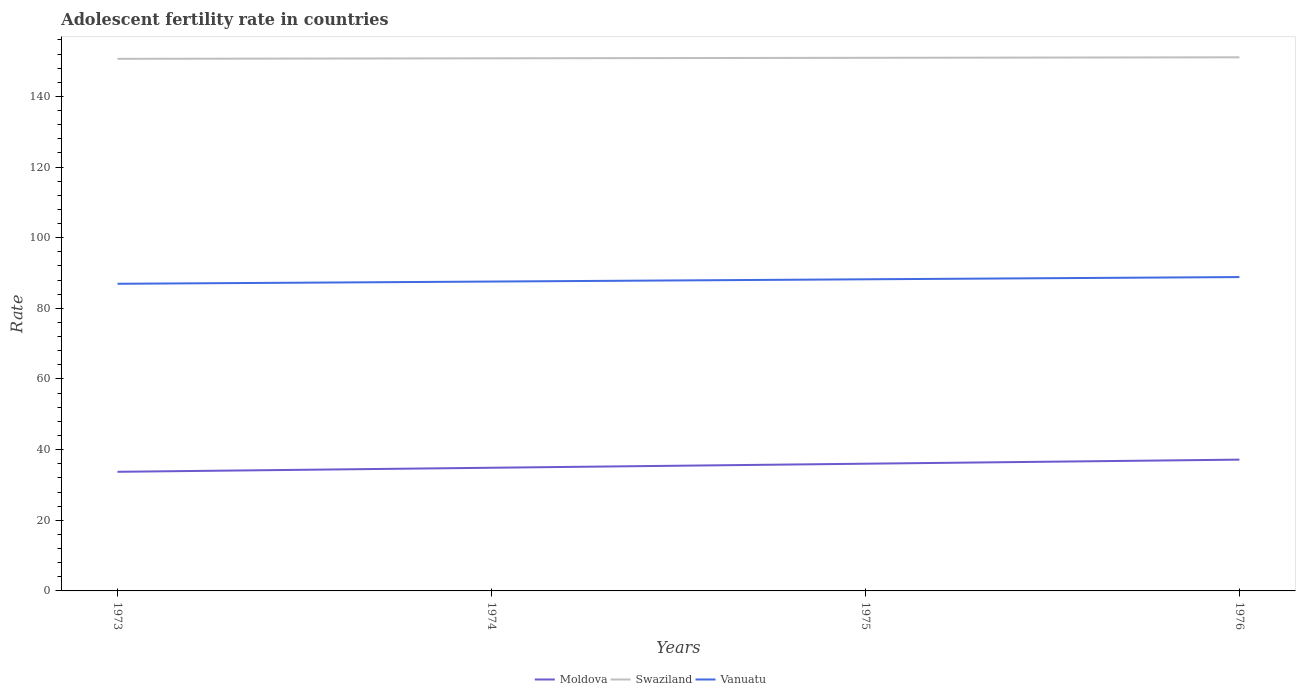How many different coloured lines are there?
Provide a short and direct response. 3. Is the number of lines equal to the number of legend labels?
Offer a very short reply. Yes. Across all years, what is the maximum adolescent fertility rate in Swaziland?
Offer a terse response. 150.65. What is the total adolescent fertility rate in Vanuatu in the graph?
Provide a succinct answer. -1.27. What is the difference between the highest and the second highest adolescent fertility rate in Vanuatu?
Make the answer very short. 1.9. How many years are there in the graph?
Ensure brevity in your answer.  4. What is the difference between two consecutive major ticks on the Y-axis?
Make the answer very short. 20. Are the values on the major ticks of Y-axis written in scientific E-notation?
Offer a very short reply. No. Does the graph contain any zero values?
Offer a terse response. No. Does the graph contain grids?
Your answer should be very brief. No. Where does the legend appear in the graph?
Offer a very short reply. Bottom center. How many legend labels are there?
Your answer should be very brief. 3. What is the title of the graph?
Make the answer very short. Adolescent fertility rate in countries. What is the label or title of the Y-axis?
Give a very brief answer. Rate. What is the Rate in Moldova in 1973?
Provide a short and direct response. 33.73. What is the Rate in Swaziland in 1973?
Your answer should be compact. 150.65. What is the Rate in Vanuatu in 1973?
Your answer should be compact. 86.96. What is the Rate in Moldova in 1974?
Provide a succinct answer. 34.87. What is the Rate of Swaziland in 1974?
Provide a short and direct response. 150.79. What is the Rate of Vanuatu in 1974?
Provide a succinct answer. 87.59. What is the Rate of Moldova in 1975?
Provide a succinct answer. 36.02. What is the Rate of Swaziland in 1975?
Your response must be concise. 150.94. What is the Rate in Vanuatu in 1975?
Provide a succinct answer. 88.23. What is the Rate in Moldova in 1976?
Provide a short and direct response. 37.17. What is the Rate of Swaziland in 1976?
Your answer should be very brief. 151.08. What is the Rate in Vanuatu in 1976?
Make the answer very short. 88.86. Across all years, what is the maximum Rate in Moldova?
Your response must be concise. 37.17. Across all years, what is the maximum Rate of Swaziland?
Provide a short and direct response. 151.08. Across all years, what is the maximum Rate in Vanuatu?
Your answer should be very brief. 88.86. Across all years, what is the minimum Rate of Moldova?
Provide a short and direct response. 33.73. Across all years, what is the minimum Rate of Swaziland?
Make the answer very short. 150.65. Across all years, what is the minimum Rate in Vanuatu?
Ensure brevity in your answer.  86.96. What is the total Rate in Moldova in the graph?
Provide a short and direct response. 141.78. What is the total Rate of Swaziland in the graph?
Give a very brief answer. 603.45. What is the total Rate of Vanuatu in the graph?
Your response must be concise. 351.63. What is the difference between the Rate of Moldova in 1973 and that in 1974?
Offer a terse response. -1.15. What is the difference between the Rate in Swaziland in 1973 and that in 1974?
Make the answer very short. -0.14. What is the difference between the Rate in Vanuatu in 1973 and that in 1974?
Your response must be concise. -0.63. What is the difference between the Rate of Moldova in 1973 and that in 1975?
Your answer should be very brief. -2.29. What is the difference between the Rate in Swaziland in 1973 and that in 1975?
Make the answer very short. -0.29. What is the difference between the Rate of Vanuatu in 1973 and that in 1975?
Offer a very short reply. -1.27. What is the difference between the Rate in Moldova in 1973 and that in 1976?
Make the answer very short. -3.44. What is the difference between the Rate in Swaziland in 1973 and that in 1976?
Provide a short and direct response. -0.43. What is the difference between the Rate in Vanuatu in 1973 and that in 1976?
Your response must be concise. -1.9. What is the difference between the Rate in Moldova in 1974 and that in 1975?
Your response must be concise. -1.15. What is the difference between the Rate in Swaziland in 1974 and that in 1975?
Give a very brief answer. -0.14. What is the difference between the Rate of Vanuatu in 1974 and that in 1975?
Make the answer very short. -0.63. What is the difference between the Rate in Moldova in 1974 and that in 1976?
Your answer should be compact. -2.29. What is the difference between the Rate of Swaziland in 1974 and that in 1976?
Ensure brevity in your answer.  -0.29. What is the difference between the Rate in Vanuatu in 1974 and that in 1976?
Make the answer very short. -1.27. What is the difference between the Rate of Moldova in 1975 and that in 1976?
Offer a terse response. -1.15. What is the difference between the Rate of Swaziland in 1975 and that in 1976?
Make the answer very short. -0.14. What is the difference between the Rate of Vanuatu in 1975 and that in 1976?
Provide a short and direct response. -0.63. What is the difference between the Rate of Moldova in 1973 and the Rate of Swaziland in 1974?
Keep it short and to the point. -117.07. What is the difference between the Rate in Moldova in 1973 and the Rate in Vanuatu in 1974?
Your answer should be very brief. -53.87. What is the difference between the Rate of Swaziland in 1973 and the Rate of Vanuatu in 1974?
Your answer should be compact. 63.06. What is the difference between the Rate in Moldova in 1973 and the Rate in Swaziland in 1975?
Provide a short and direct response. -117.21. What is the difference between the Rate of Moldova in 1973 and the Rate of Vanuatu in 1975?
Offer a very short reply. -54.5. What is the difference between the Rate of Swaziland in 1973 and the Rate of Vanuatu in 1975?
Keep it short and to the point. 62.42. What is the difference between the Rate of Moldova in 1973 and the Rate of Swaziland in 1976?
Provide a succinct answer. -117.35. What is the difference between the Rate of Moldova in 1973 and the Rate of Vanuatu in 1976?
Your answer should be compact. -55.13. What is the difference between the Rate of Swaziland in 1973 and the Rate of Vanuatu in 1976?
Keep it short and to the point. 61.79. What is the difference between the Rate of Moldova in 1974 and the Rate of Swaziland in 1975?
Your answer should be compact. -116.06. What is the difference between the Rate of Moldova in 1974 and the Rate of Vanuatu in 1975?
Offer a terse response. -53.35. What is the difference between the Rate of Swaziland in 1974 and the Rate of Vanuatu in 1975?
Your answer should be compact. 62.57. What is the difference between the Rate in Moldova in 1974 and the Rate in Swaziland in 1976?
Your response must be concise. -116.21. What is the difference between the Rate in Moldova in 1974 and the Rate in Vanuatu in 1976?
Keep it short and to the point. -53.99. What is the difference between the Rate of Swaziland in 1974 and the Rate of Vanuatu in 1976?
Your answer should be very brief. 61.93. What is the difference between the Rate of Moldova in 1975 and the Rate of Swaziland in 1976?
Offer a terse response. -115.06. What is the difference between the Rate of Moldova in 1975 and the Rate of Vanuatu in 1976?
Your answer should be compact. -52.84. What is the difference between the Rate in Swaziland in 1975 and the Rate in Vanuatu in 1976?
Your response must be concise. 62.08. What is the average Rate in Moldova per year?
Offer a very short reply. 35.45. What is the average Rate in Swaziland per year?
Your answer should be very brief. 150.86. What is the average Rate in Vanuatu per year?
Ensure brevity in your answer.  87.91. In the year 1973, what is the difference between the Rate of Moldova and Rate of Swaziland?
Give a very brief answer. -116.92. In the year 1973, what is the difference between the Rate of Moldova and Rate of Vanuatu?
Your response must be concise. -53.23. In the year 1973, what is the difference between the Rate in Swaziland and Rate in Vanuatu?
Offer a very short reply. 63.69. In the year 1974, what is the difference between the Rate of Moldova and Rate of Swaziland?
Ensure brevity in your answer.  -115.92. In the year 1974, what is the difference between the Rate in Moldova and Rate in Vanuatu?
Offer a terse response. -52.72. In the year 1974, what is the difference between the Rate of Swaziland and Rate of Vanuatu?
Offer a terse response. 63.2. In the year 1975, what is the difference between the Rate in Moldova and Rate in Swaziland?
Provide a succinct answer. -114.92. In the year 1975, what is the difference between the Rate of Moldova and Rate of Vanuatu?
Your response must be concise. -52.21. In the year 1975, what is the difference between the Rate in Swaziland and Rate in Vanuatu?
Your answer should be very brief. 62.71. In the year 1976, what is the difference between the Rate in Moldova and Rate in Swaziland?
Offer a terse response. -113.91. In the year 1976, what is the difference between the Rate in Moldova and Rate in Vanuatu?
Offer a terse response. -51.69. In the year 1976, what is the difference between the Rate of Swaziland and Rate of Vanuatu?
Your response must be concise. 62.22. What is the ratio of the Rate in Moldova in 1973 to that in 1974?
Offer a terse response. 0.97. What is the ratio of the Rate of Swaziland in 1973 to that in 1974?
Give a very brief answer. 1. What is the ratio of the Rate of Vanuatu in 1973 to that in 1974?
Offer a terse response. 0.99. What is the ratio of the Rate in Moldova in 1973 to that in 1975?
Offer a terse response. 0.94. What is the ratio of the Rate in Vanuatu in 1973 to that in 1975?
Your response must be concise. 0.99. What is the ratio of the Rate in Moldova in 1973 to that in 1976?
Make the answer very short. 0.91. What is the ratio of the Rate of Swaziland in 1973 to that in 1976?
Offer a terse response. 1. What is the ratio of the Rate in Vanuatu in 1973 to that in 1976?
Make the answer very short. 0.98. What is the ratio of the Rate of Moldova in 1974 to that in 1975?
Make the answer very short. 0.97. What is the ratio of the Rate of Vanuatu in 1974 to that in 1975?
Provide a short and direct response. 0.99. What is the ratio of the Rate in Moldova in 1974 to that in 1976?
Make the answer very short. 0.94. What is the ratio of the Rate of Vanuatu in 1974 to that in 1976?
Offer a terse response. 0.99. What is the ratio of the Rate in Moldova in 1975 to that in 1976?
Offer a terse response. 0.97. What is the ratio of the Rate in Swaziland in 1975 to that in 1976?
Offer a terse response. 1. What is the ratio of the Rate of Vanuatu in 1975 to that in 1976?
Your answer should be compact. 0.99. What is the difference between the highest and the second highest Rate of Moldova?
Your answer should be compact. 1.15. What is the difference between the highest and the second highest Rate of Swaziland?
Make the answer very short. 0.14. What is the difference between the highest and the second highest Rate in Vanuatu?
Your answer should be very brief. 0.63. What is the difference between the highest and the lowest Rate in Moldova?
Keep it short and to the point. 3.44. What is the difference between the highest and the lowest Rate in Swaziland?
Keep it short and to the point. 0.43. What is the difference between the highest and the lowest Rate of Vanuatu?
Ensure brevity in your answer.  1.9. 